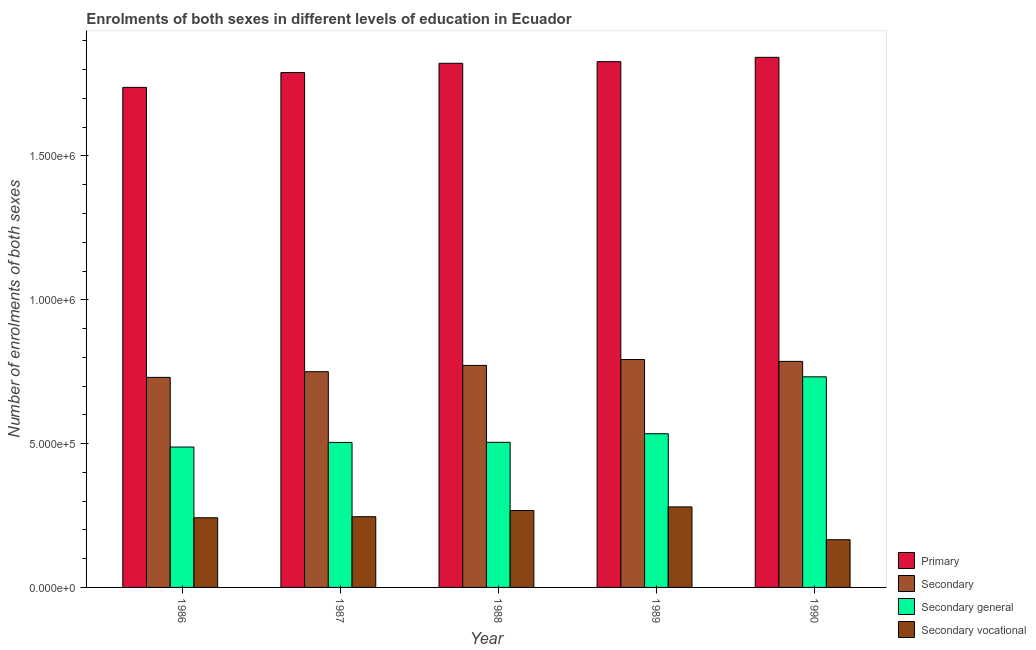How many different coloured bars are there?
Give a very brief answer. 4. Are the number of bars on each tick of the X-axis equal?
Provide a short and direct response. Yes. How many bars are there on the 1st tick from the right?
Your answer should be very brief. 4. What is the number of enrolments in secondary general education in 1987?
Make the answer very short. 5.04e+05. Across all years, what is the maximum number of enrolments in secondary vocational education?
Your answer should be compact. 2.80e+05. Across all years, what is the minimum number of enrolments in secondary education?
Your answer should be compact. 7.30e+05. In which year was the number of enrolments in primary education maximum?
Offer a very short reply. 1990. What is the total number of enrolments in primary education in the graph?
Ensure brevity in your answer.  9.02e+06. What is the difference between the number of enrolments in secondary general education in 1987 and that in 1988?
Your answer should be very brief. -353. What is the difference between the number of enrolments in secondary education in 1989 and the number of enrolments in secondary vocational education in 1986?
Make the answer very short. 6.21e+04. What is the average number of enrolments in secondary general education per year?
Provide a short and direct response. 5.53e+05. In the year 1987, what is the difference between the number of enrolments in secondary vocational education and number of enrolments in secondary education?
Your answer should be compact. 0. What is the ratio of the number of enrolments in secondary education in 1987 to that in 1989?
Ensure brevity in your answer.  0.95. Is the number of enrolments in secondary general education in 1987 less than that in 1990?
Your answer should be compact. Yes. Is the difference between the number of enrolments in primary education in 1986 and 1990 greater than the difference between the number of enrolments in secondary education in 1986 and 1990?
Give a very brief answer. No. What is the difference between the highest and the second highest number of enrolments in primary education?
Give a very brief answer. 1.50e+04. What is the difference between the highest and the lowest number of enrolments in secondary education?
Give a very brief answer. 6.21e+04. In how many years, is the number of enrolments in secondary vocational education greater than the average number of enrolments in secondary vocational education taken over all years?
Provide a short and direct response. 4. Is the sum of the number of enrolments in secondary vocational education in 1987 and 1990 greater than the maximum number of enrolments in primary education across all years?
Provide a succinct answer. Yes. What does the 2nd bar from the left in 1986 represents?
Offer a very short reply. Secondary. What does the 1st bar from the right in 1989 represents?
Ensure brevity in your answer.  Secondary vocational. Is it the case that in every year, the sum of the number of enrolments in primary education and number of enrolments in secondary education is greater than the number of enrolments in secondary general education?
Provide a succinct answer. Yes. Are the values on the major ticks of Y-axis written in scientific E-notation?
Ensure brevity in your answer.  Yes. What is the title of the graph?
Your response must be concise. Enrolments of both sexes in different levels of education in Ecuador. Does "Secondary general" appear as one of the legend labels in the graph?
Your answer should be very brief. Yes. What is the label or title of the X-axis?
Keep it short and to the point. Year. What is the label or title of the Y-axis?
Make the answer very short. Number of enrolments of both sexes. What is the Number of enrolments of both sexes of Primary in 1986?
Provide a succinct answer. 1.74e+06. What is the Number of enrolments of both sexes of Secondary in 1986?
Ensure brevity in your answer.  7.30e+05. What is the Number of enrolments of both sexes of Secondary general in 1986?
Provide a short and direct response. 4.88e+05. What is the Number of enrolments of both sexes of Secondary vocational in 1986?
Your response must be concise. 2.42e+05. What is the Number of enrolments of both sexes of Primary in 1987?
Your response must be concise. 1.79e+06. What is the Number of enrolments of both sexes in Secondary in 1987?
Your response must be concise. 7.50e+05. What is the Number of enrolments of both sexes of Secondary general in 1987?
Ensure brevity in your answer.  5.04e+05. What is the Number of enrolments of both sexes of Secondary vocational in 1987?
Provide a succinct answer. 2.46e+05. What is the Number of enrolments of both sexes of Primary in 1988?
Offer a very short reply. 1.82e+06. What is the Number of enrolments of both sexes in Secondary in 1988?
Offer a terse response. 7.72e+05. What is the Number of enrolments of both sexes in Secondary general in 1988?
Provide a succinct answer. 5.04e+05. What is the Number of enrolments of both sexes in Secondary vocational in 1988?
Offer a terse response. 2.67e+05. What is the Number of enrolments of both sexes in Primary in 1989?
Your answer should be very brief. 1.83e+06. What is the Number of enrolments of both sexes of Secondary in 1989?
Your answer should be compact. 7.92e+05. What is the Number of enrolments of both sexes of Secondary general in 1989?
Keep it short and to the point. 5.34e+05. What is the Number of enrolments of both sexes in Secondary vocational in 1989?
Make the answer very short. 2.80e+05. What is the Number of enrolments of both sexes in Primary in 1990?
Your answer should be compact. 1.84e+06. What is the Number of enrolments of both sexes in Secondary in 1990?
Provide a succinct answer. 7.86e+05. What is the Number of enrolments of both sexes of Secondary general in 1990?
Provide a succinct answer. 7.32e+05. What is the Number of enrolments of both sexes in Secondary vocational in 1990?
Make the answer very short. 1.66e+05. Across all years, what is the maximum Number of enrolments of both sexes in Primary?
Your answer should be very brief. 1.84e+06. Across all years, what is the maximum Number of enrolments of both sexes in Secondary?
Offer a terse response. 7.92e+05. Across all years, what is the maximum Number of enrolments of both sexes of Secondary general?
Give a very brief answer. 7.32e+05. Across all years, what is the maximum Number of enrolments of both sexes of Secondary vocational?
Your response must be concise. 2.80e+05. Across all years, what is the minimum Number of enrolments of both sexes in Primary?
Give a very brief answer. 1.74e+06. Across all years, what is the minimum Number of enrolments of both sexes in Secondary?
Your answer should be very brief. 7.30e+05. Across all years, what is the minimum Number of enrolments of both sexes in Secondary general?
Your answer should be compact. 4.88e+05. Across all years, what is the minimum Number of enrolments of both sexes in Secondary vocational?
Ensure brevity in your answer.  1.66e+05. What is the total Number of enrolments of both sexes of Primary in the graph?
Provide a succinct answer. 9.02e+06. What is the total Number of enrolments of both sexes of Secondary in the graph?
Your answer should be compact. 3.83e+06. What is the total Number of enrolments of both sexes of Secondary general in the graph?
Make the answer very short. 2.76e+06. What is the total Number of enrolments of both sexes of Secondary vocational in the graph?
Offer a terse response. 1.20e+06. What is the difference between the Number of enrolments of both sexes in Primary in 1986 and that in 1987?
Your answer should be very brief. -5.14e+04. What is the difference between the Number of enrolments of both sexes of Secondary in 1986 and that in 1987?
Provide a succinct answer. -1.98e+04. What is the difference between the Number of enrolments of both sexes of Secondary general in 1986 and that in 1987?
Make the answer very short. -1.60e+04. What is the difference between the Number of enrolments of both sexes of Secondary vocational in 1986 and that in 1987?
Ensure brevity in your answer.  -3742. What is the difference between the Number of enrolments of both sexes in Primary in 1986 and that in 1988?
Your answer should be compact. -8.37e+04. What is the difference between the Number of enrolments of both sexes of Secondary in 1986 and that in 1988?
Provide a short and direct response. -4.17e+04. What is the difference between the Number of enrolments of both sexes in Secondary general in 1986 and that in 1988?
Make the answer very short. -1.64e+04. What is the difference between the Number of enrolments of both sexes in Secondary vocational in 1986 and that in 1988?
Give a very brief answer. -2.53e+04. What is the difference between the Number of enrolments of both sexes of Primary in 1986 and that in 1989?
Provide a short and direct response. -8.94e+04. What is the difference between the Number of enrolments of both sexes in Secondary in 1986 and that in 1989?
Provide a succinct answer. -6.21e+04. What is the difference between the Number of enrolments of both sexes of Secondary general in 1986 and that in 1989?
Give a very brief answer. -4.63e+04. What is the difference between the Number of enrolments of both sexes in Secondary vocational in 1986 and that in 1989?
Provide a succinct answer. -3.78e+04. What is the difference between the Number of enrolments of both sexes in Primary in 1986 and that in 1990?
Your response must be concise. -1.04e+05. What is the difference between the Number of enrolments of both sexes in Secondary in 1986 and that in 1990?
Ensure brevity in your answer.  -5.56e+04. What is the difference between the Number of enrolments of both sexes of Secondary general in 1986 and that in 1990?
Your answer should be very brief. -2.44e+05. What is the difference between the Number of enrolments of both sexes in Secondary vocational in 1986 and that in 1990?
Keep it short and to the point. 7.63e+04. What is the difference between the Number of enrolments of both sexes in Primary in 1987 and that in 1988?
Ensure brevity in your answer.  -3.23e+04. What is the difference between the Number of enrolments of both sexes in Secondary in 1987 and that in 1988?
Offer a terse response. -2.19e+04. What is the difference between the Number of enrolments of both sexes of Secondary general in 1987 and that in 1988?
Keep it short and to the point. -353. What is the difference between the Number of enrolments of both sexes of Secondary vocational in 1987 and that in 1988?
Provide a succinct answer. -2.16e+04. What is the difference between the Number of enrolments of both sexes in Primary in 1987 and that in 1989?
Your response must be concise. -3.79e+04. What is the difference between the Number of enrolments of both sexes of Secondary in 1987 and that in 1989?
Offer a terse response. -4.23e+04. What is the difference between the Number of enrolments of both sexes in Secondary general in 1987 and that in 1989?
Your response must be concise. -3.02e+04. What is the difference between the Number of enrolments of both sexes of Secondary vocational in 1987 and that in 1989?
Offer a terse response. -3.41e+04. What is the difference between the Number of enrolments of both sexes in Primary in 1987 and that in 1990?
Offer a very short reply. -5.30e+04. What is the difference between the Number of enrolments of both sexes of Secondary in 1987 and that in 1990?
Offer a terse response. -3.58e+04. What is the difference between the Number of enrolments of both sexes in Secondary general in 1987 and that in 1990?
Keep it short and to the point. -2.28e+05. What is the difference between the Number of enrolments of both sexes of Secondary vocational in 1987 and that in 1990?
Keep it short and to the point. 8.00e+04. What is the difference between the Number of enrolments of both sexes in Primary in 1988 and that in 1989?
Give a very brief answer. -5668. What is the difference between the Number of enrolments of both sexes in Secondary in 1988 and that in 1989?
Offer a very short reply. -2.04e+04. What is the difference between the Number of enrolments of both sexes in Secondary general in 1988 and that in 1989?
Offer a very short reply. -2.99e+04. What is the difference between the Number of enrolments of both sexes of Secondary vocational in 1988 and that in 1989?
Provide a short and direct response. -1.25e+04. What is the difference between the Number of enrolments of both sexes of Primary in 1988 and that in 1990?
Offer a very short reply. -2.07e+04. What is the difference between the Number of enrolments of both sexes in Secondary in 1988 and that in 1990?
Keep it short and to the point. -1.39e+04. What is the difference between the Number of enrolments of both sexes in Secondary general in 1988 and that in 1990?
Your answer should be very brief. -2.28e+05. What is the difference between the Number of enrolments of both sexes of Secondary vocational in 1988 and that in 1990?
Give a very brief answer. 1.02e+05. What is the difference between the Number of enrolments of both sexes in Primary in 1989 and that in 1990?
Your answer should be compact. -1.50e+04. What is the difference between the Number of enrolments of both sexes of Secondary in 1989 and that in 1990?
Your answer should be very brief. 6453. What is the difference between the Number of enrolments of both sexes in Secondary general in 1989 and that in 1990?
Give a very brief answer. -1.98e+05. What is the difference between the Number of enrolments of both sexes in Secondary vocational in 1989 and that in 1990?
Your answer should be very brief. 1.14e+05. What is the difference between the Number of enrolments of both sexes in Primary in 1986 and the Number of enrolments of both sexes in Secondary in 1987?
Offer a terse response. 9.89e+05. What is the difference between the Number of enrolments of both sexes in Primary in 1986 and the Number of enrolments of both sexes in Secondary general in 1987?
Your answer should be very brief. 1.23e+06. What is the difference between the Number of enrolments of both sexes in Primary in 1986 and the Number of enrolments of both sexes in Secondary vocational in 1987?
Ensure brevity in your answer.  1.49e+06. What is the difference between the Number of enrolments of both sexes of Secondary in 1986 and the Number of enrolments of both sexes of Secondary general in 1987?
Make the answer very short. 2.26e+05. What is the difference between the Number of enrolments of both sexes of Secondary in 1986 and the Number of enrolments of both sexes of Secondary vocational in 1987?
Your answer should be compact. 4.84e+05. What is the difference between the Number of enrolments of both sexes of Secondary general in 1986 and the Number of enrolments of both sexes of Secondary vocational in 1987?
Provide a short and direct response. 2.42e+05. What is the difference between the Number of enrolments of both sexes in Primary in 1986 and the Number of enrolments of both sexes in Secondary in 1988?
Give a very brief answer. 9.67e+05. What is the difference between the Number of enrolments of both sexes in Primary in 1986 and the Number of enrolments of both sexes in Secondary general in 1988?
Your answer should be compact. 1.23e+06. What is the difference between the Number of enrolments of both sexes of Primary in 1986 and the Number of enrolments of both sexes of Secondary vocational in 1988?
Offer a very short reply. 1.47e+06. What is the difference between the Number of enrolments of both sexes of Secondary in 1986 and the Number of enrolments of both sexes of Secondary general in 1988?
Offer a terse response. 2.26e+05. What is the difference between the Number of enrolments of both sexes in Secondary in 1986 and the Number of enrolments of both sexes in Secondary vocational in 1988?
Provide a short and direct response. 4.63e+05. What is the difference between the Number of enrolments of both sexes of Secondary general in 1986 and the Number of enrolments of both sexes of Secondary vocational in 1988?
Offer a very short reply. 2.21e+05. What is the difference between the Number of enrolments of both sexes in Primary in 1986 and the Number of enrolments of both sexes in Secondary in 1989?
Offer a terse response. 9.46e+05. What is the difference between the Number of enrolments of both sexes of Primary in 1986 and the Number of enrolments of both sexes of Secondary general in 1989?
Keep it short and to the point. 1.20e+06. What is the difference between the Number of enrolments of both sexes of Primary in 1986 and the Number of enrolments of both sexes of Secondary vocational in 1989?
Give a very brief answer. 1.46e+06. What is the difference between the Number of enrolments of both sexes of Secondary in 1986 and the Number of enrolments of both sexes of Secondary general in 1989?
Offer a very short reply. 1.96e+05. What is the difference between the Number of enrolments of both sexes of Secondary in 1986 and the Number of enrolments of both sexes of Secondary vocational in 1989?
Provide a succinct answer. 4.50e+05. What is the difference between the Number of enrolments of both sexes of Secondary general in 1986 and the Number of enrolments of both sexes of Secondary vocational in 1989?
Keep it short and to the point. 2.08e+05. What is the difference between the Number of enrolments of both sexes of Primary in 1986 and the Number of enrolments of both sexes of Secondary in 1990?
Your answer should be very brief. 9.53e+05. What is the difference between the Number of enrolments of both sexes of Primary in 1986 and the Number of enrolments of both sexes of Secondary general in 1990?
Your response must be concise. 1.01e+06. What is the difference between the Number of enrolments of both sexes of Primary in 1986 and the Number of enrolments of both sexes of Secondary vocational in 1990?
Ensure brevity in your answer.  1.57e+06. What is the difference between the Number of enrolments of both sexes in Secondary in 1986 and the Number of enrolments of both sexes in Secondary general in 1990?
Ensure brevity in your answer.  -1970. What is the difference between the Number of enrolments of both sexes in Secondary in 1986 and the Number of enrolments of both sexes in Secondary vocational in 1990?
Offer a terse response. 5.64e+05. What is the difference between the Number of enrolments of both sexes of Secondary general in 1986 and the Number of enrolments of both sexes of Secondary vocational in 1990?
Make the answer very short. 3.22e+05. What is the difference between the Number of enrolments of both sexes of Primary in 1987 and the Number of enrolments of both sexes of Secondary in 1988?
Keep it short and to the point. 1.02e+06. What is the difference between the Number of enrolments of both sexes in Primary in 1987 and the Number of enrolments of both sexes in Secondary general in 1988?
Offer a terse response. 1.29e+06. What is the difference between the Number of enrolments of both sexes in Primary in 1987 and the Number of enrolments of both sexes in Secondary vocational in 1988?
Give a very brief answer. 1.52e+06. What is the difference between the Number of enrolments of both sexes of Secondary in 1987 and the Number of enrolments of both sexes of Secondary general in 1988?
Offer a terse response. 2.46e+05. What is the difference between the Number of enrolments of both sexes in Secondary in 1987 and the Number of enrolments of both sexes in Secondary vocational in 1988?
Your answer should be very brief. 4.83e+05. What is the difference between the Number of enrolments of both sexes in Secondary general in 1987 and the Number of enrolments of both sexes in Secondary vocational in 1988?
Give a very brief answer. 2.37e+05. What is the difference between the Number of enrolments of both sexes in Primary in 1987 and the Number of enrolments of both sexes in Secondary in 1989?
Give a very brief answer. 9.98e+05. What is the difference between the Number of enrolments of both sexes in Primary in 1987 and the Number of enrolments of both sexes in Secondary general in 1989?
Offer a terse response. 1.26e+06. What is the difference between the Number of enrolments of both sexes of Primary in 1987 and the Number of enrolments of both sexes of Secondary vocational in 1989?
Offer a terse response. 1.51e+06. What is the difference between the Number of enrolments of both sexes of Secondary in 1987 and the Number of enrolments of both sexes of Secondary general in 1989?
Your answer should be compact. 2.16e+05. What is the difference between the Number of enrolments of both sexes in Secondary in 1987 and the Number of enrolments of both sexes in Secondary vocational in 1989?
Ensure brevity in your answer.  4.70e+05. What is the difference between the Number of enrolments of both sexes of Secondary general in 1987 and the Number of enrolments of both sexes of Secondary vocational in 1989?
Your response must be concise. 2.24e+05. What is the difference between the Number of enrolments of both sexes of Primary in 1987 and the Number of enrolments of both sexes of Secondary in 1990?
Your answer should be very brief. 1.00e+06. What is the difference between the Number of enrolments of both sexes in Primary in 1987 and the Number of enrolments of both sexes in Secondary general in 1990?
Offer a terse response. 1.06e+06. What is the difference between the Number of enrolments of both sexes of Primary in 1987 and the Number of enrolments of both sexes of Secondary vocational in 1990?
Your answer should be compact. 1.62e+06. What is the difference between the Number of enrolments of both sexes in Secondary in 1987 and the Number of enrolments of both sexes in Secondary general in 1990?
Provide a succinct answer. 1.78e+04. What is the difference between the Number of enrolments of both sexes of Secondary in 1987 and the Number of enrolments of both sexes of Secondary vocational in 1990?
Provide a short and direct response. 5.84e+05. What is the difference between the Number of enrolments of both sexes of Secondary general in 1987 and the Number of enrolments of both sexes of Secondary vocational in 1990?
Give a very brief answer. 3.38e+05. What is the difference between the Number of enrolments of both sexes in Primary in 1988 and the Number of enrolments of both sexes in Secondary in 1989?
Offer a very short reply. 1.03e+06. What is the difference between the Number of enrolments of both sexes in Primary in 1988 and the Number of enrolments of both sexes in Secondary general in 1989?
Provide a short and direct response. 1.29e+06. What is the difference between the Number of enrolments of both sexes in Primary in 1988 and the Number of enrolments of both sexes in Secondary vocational in 1989?
Provide a succinct answer. 1.54e+06. What is the difference between the Number of enrolments of both sexes in Secondary in 1988 and the Number of enrolments of both sexes in Secondary general in 1989?
Your answer should be very brief. 2.38e+05. What is the difference between the Number of enrolments of both sexes in Secondary in 1988 and the Number of enrolments of both sexes in Secondary vocational in 1989?
Keep it short and to the point. 4.92e+05. What is the difference between the Number of enrolments of both sexes of Secondary general in 1988 and the Number of enrolments of both sexes of Secondary vocational in 1989?
Your answer should be compact. 2.24e+05. What is the difference between the Number of enrolments of both sexes in Primary in 1988 and the Number of enrolments of both sexes in Secondary in 1990?
Your answer should be very brief. 1.04e+06. What is the difference between the Number of enrolments of both sexes of Primary in 1988 and the Number of enrolments of both sexes of Secondary general in 1990?
Give a very brief answer. 1.09e+06. What is the difference between the Number of enrolments of both sexes of Primary in 1988 and the Number of enrolments of both sexes of Secondary vocational in 1990?
Your answer should be very brief. 1.66e+06. What is the difference between the Number of enrolments of both sexes of Secondary in 1988 and the Number of enrolments of both sexes of Secondary general in 1990?
Give a very brief answer. 3.97e+04. What is the difference between the Number of enrolments of both sexes in Secondary in 1988 and the Number of enrolments of both sexes in Secondary vocational in 1990?
Your answer should be very brief. 6.06e+05. What is the difference between the Number of enrolments of both sexes of Secondary general in 1988 and the Number of enrolments of both sexes of Secondary vocational in 1990?
Offer a very short reply. 3.39e+05. What is the difference between the Number of enrolments of both sexes in Primary in 1989 and the Number of enrolments of both sexes in Secondary in 1990?
Ensure brevity in your answer.  1.04e+06. What is the difference between the Number of enrolments of both sexes of Primary in 1989 and the Number of enrolments of both sexes of Secondary general in 1990?
Ensure brevity in your answer.  1.10e+06. What is the difference between the Number of enrolments of both sexes of Primary in 1989 and the Number of enrolments of both sexes of Secondary vocational in 1990?
Your answer should be very brief. 1.66e+06. What is the difference between the Number of enrolments of both sexes in Secondary in 1989 and the Number of enrolments of both sexes in Secondary general in 1990?
Your answer should be very brief. 6.01e+04. What is the difference between the Number of enrolments of both sexes of Secondary in 1989 and the Number of enrolments of both sexes of Secondary vocational in 1990?
Make the answer very short. 6.26e+05. What is the difference between the Number of enrolments of both sexes in Secondary general in 1989 and the Number of enrolments of both sexes in Secondary vocational in 1990?
Your response must be concise. 3.69e+05. What is the average Number of enrolments of both sexes of Primary per year?
Make the answer very short. 1.80e+06. What is the average Number of enrolments of both sexes of Secondary per year?
Provide a short and direct response. 7.66e+05. What is the average Number of enrolments of both sexes in Secondary general per year?
Ensure brevity in your answer.  5.53e+05. What is the average Number of enrolments of both sexes of Secondary vocational per year?
Provide a succinct answer. 2.40e+05. In the year 1986, what is the difference between the Number of enrolments of both sexes of Primary and Number of enrolments of both sexes of Secondary?
Your answer should be very brief. 1.01e+06. In the year 1986, what is the difference between the Number of enrolments of both sexes of Primary and Number of enrolments of both sexes of Secondary general?
Make the answer very short. 1.25e+06. In the year 1986, what is the difference between the Number of enrolments of both sexes of Primary and Number of enrolments of both sexes of Secondary vocational?
Make the answer very short. 1.50e+06. In the year 1986, what is the difference between the Number of enrolments of both sexes of Secondary and Number of enrolments of both sexes of Secondary general?
Keep it short and to the point. 2.42e+05. In the year 1986, what is the difference between the Number of enrolments of both sexes of Secondary and Number of enrolments of both sexes of Secondary vocational?
Provide a succinct answer. 4.88e+05. In the year 1986, what is the difference between the Number of enrolments of both sexes in Secondary general and Number of enrolments of both sexes in Secondary vocational?
Make the answer very short. 2.46e+05. In the year 1987, what is the difference between the Number of enrolments of both sexes of Primary and Number of enrolments of both sexes of Secondary?
Your answer should be compact. 1.04e+06. In the year 1987, what is the difference between the Number of enrolments of both sexes of Primary and Number of enrolments of both sexes of Secondary general?
Offer a very short reply. 1.29e+06. In the year 1987, what is the difference between the Number of enrolments of both sexes in Primary and Number of enrolments of both sexes in Secondary vocational?
Provide a short and direct response. 1.54e+06. In the year 1987, what is the difference between the Number of enrolments of both sexes in Secondary and Number of enrolments of both sexes in Secondary general?
Offer a terse response. 2.46e+05. In the year 1987, what is the difference between the Number of enrolments of both sexes in Secondary and Number of enrolments of both sexes in Secondary vocational?
Provide a succinct answer. 5.04e+05. In the year 1987, what is the difference between the Number of enrolments of both sexes of Secondary general and Number of enrolments of both sexes of Secondary vocational?
Your answer should be very brief. 2.58e+05. In the year 1988, what is the difference between the Number of enrolments of both sexes in Primary and Number of enrolments of both sexes in Secondary?
Your answer should be compact. 1.05e+06. In the year 1988, what is the difference between the Number of enrolments of both sexes in Primary and Number of enrolments of both sexes in Secondary general?
Give a very brief answer. 1.32e+06. In the year 1988, what is the difference between the Number of enrolments of both sexes of Primary and Number of enrolments of both sexes of Secondary vocational?
Ensure brevity in your answer.  1.55e+06. In the year 1988, what is the difference between the Number of enrolments of both sexes in Secondary and Number of enrolments of both sexes in Secondary general?
Offer a very short reply. 2.67e+05. In the year 1988, what is the difference between the Number of enrolments of both sexes of Secondary and Number of enrolments of both sexes of Secondary vocational?
Your response must be concise. 5.04e+05. In the year 1988, what is the difference between the Number of enrolments of both sexes in Secondary general and Number of enrolments of both sexes in Secondary vocational?
Give a very brief answer. 2.37e+05. In the year 1989, what is the difference between the Number of enrolments of both sexes in Primary and Number of enrolments of both sexes in Secondary?
Offer a very short reply. 1.04e+06. In the year 1989, what is the difference between the Number of enrolments of both sexes in Primary and Number of enrolments of both sexes in Secondary general?
Ensure brevity in your answer.  1.29e+06. In the year 1989, what is the difference between the Number of enrolments of both sexes in Primary and Number of enrolments of both sexes in Secondary vocational?
Offer a terse response. 1.55e+06. In the year 1989, what is the difference between the Number of enrolments of both sexes of Secondary and Number of enrolments of both sexes of Secondary general?
Ensure brevity in your answer.  2.58e+05. In the year 1989, what is the difference between the Number of enrolments of both sexes of Secondary and Number of enrolments of both sexes of Secondary vocational?
Keep it short and to the point. 5.12e+05. In the year 1989, what is the difference between the Number of enrolments of both sexes in Secondary general and Number of enrolments of both sexes in Secondary vocational?
Your answer should be compact. 2.54e+05. In the year 1990, what is the difference between the Number of enrolments of both sexes of Primary and Number of enrolments of both sexes of Secondary?
Offer a terse response. 1.06e+06. In the year 1990, what is the difference between the Number of enrolments of both sexes in Primary and Number of enrolments of both sexes in Secondary general?
Your answer should be very brief. 1.11e+06. In the year 1990, what is the difference between the Number of enrolments of both sexes of Primary and Number of enrolments of both sexes of Secondary vocational?
Your answer should be very brief. 1.68e+06. In the year 1990, what is the difference between the Number of enrolments of both sexes in Secondary and Number of enrolments of both sexes in Secondary general?
Ensure brevity in your answer.  5.36e+04. In the year 1990, what is the difference between the Number of enrolments of both sexes of Secondary and Number of enrolments of both sexes of Secondary vocational?
Your answer should be very brief. 6.20e+05. In the year 1990, what is the difference between the Number of enrolments of both sexes of Secondary general and Number of enrolments of both sexes of Secondary vocational?
Your answer should be very brief. 5.66e+05. What is the ratio of the Number of enrolments of both sexes of Primary in 1986 to that in 1987?
Your response must be concise. 0.97. What is the ratio of the Number of enrolments of both sexes in Secondary in 1986 to that in 1987?
Your answer should be compact. 0.97. What is the ratio of the Number of enrolments of both sexes in Secondary general in 1986 to that in 1987?
Ensure brevity in your answer.  0.97. What is the ratio of the Number of enrolments of both sexes in Primary in 1986 to that in 1988?
Provide a short and direct response. 0.95. What is the ratio of the Number of enrolments of both sexes in Secondary in 1986 to that in 1988?
Provide a succinct answer. 0.95. What is the ratio of the Number of enrolments of both sexes in Secondary general in 1986 to that in 1988?
Provide a succinct answer. 0.97. What is the ratio of the Number of enrolments of both sexes of Secondary vocational in 1986 to that in 1988?
Make the answer very short. 0.91. What is the ratio of the Number of enrolments of both sexes of Primary in 1986 to that in 1989?
Keep it short and to the point. 0.95. What is the ratio of the Number of enrolments of both sexes of Secondary in 1986 to that in 1989?
Provide a short and direct response. 0.92. What is the ratio of the Number of enrolments of both sexes in Secondary general in 1986 to that in 1989?
Ensure brevity in your answer.  0.91. What is the ratio of the Number of enrolments of both sexes in Secondary vocational in 1986 to that in 1989?
Ensure brevity in your answer.  0.86. What is the ratio of the Number of enrolments of both sexes in Primary in 1986 to that in 1990?
Provide a short and direct response. 0.94. What is the ratio of the Number of enrolments of both sexes in Secondary in 1986 to that in 1990?
Your response must be concise. 0.93. What is the ratio of the Number of enrolments of both sexes in Secondary general in 1986 to that in 1990?
Your answer should be very brief. 0.67. What is the ratio of the Number of enrolments of both sexes of Secondary vocational in 1986 to that in 1990?
Keep it short and to the point. 1.46. What is the ratio of the Number of enrolments of both sexes in Primary in 1987 to that in 1988?
Give a very brief answer. 0.98. What is the ratio of the Number of enrolments of both sexes of Secondary in 1987 to that in 1988?
Keep it short and to the point. 0.97. What is the ratio of the Number of enrolments of both sexes in Secondary vocational in 1987 to that in 1988?
Offer a terse response. 0.92. What is the ratio of the Number of enrolments of both sexes in Primary in 1987 to that in 1989?
Provide a succinct answer. 0.98. What is the ratio of the Number of enrolments of both sexes in Secondary in 1987 to that in 1989?
Your answer should be compact. 0.95. What is the ratio of the Number of enrolments of both sexes in Secondary general in 1987 to that in 1989?
Offer a very short reply. 0.94. What is the ratio of the Number of enrolments of both sexes in Secondary vocational in 1987 to that in 1989?
Offer a very short reply. 0.88. What is the ratio of the Number of enrolments of both sexes in Primary in 1987 to that in 1990?
Keep it short and to the point. 0.97. What is the ratio of the Number of enrolments of both sexes of Secondary in 1987 to that in 1990?
Give a very brief answer. 0.95. What is the ratio of the Number of enrolments of both sexes of Secondary general in 1987 to that in 1990?
Your answer should be very brief. 0.69. What is the ratio of the Number of enrolments of both sexes of Secondary vocational in 1987 to that in 1990?
Your answer should be compact. 1.48. What is the ratio of the Number of enrolments of both sexes of Secondary in 1988 to that in 1989?
Offer a terse response. 0.97. What is the ratio of the Number of enrolments of both sexes of Secondary general in 1988 to that in 1989?
Offer a very short reply. 0.94. What is the ratio of the Number of enrolments of both sexes of Secondary vocational in 1988 to that in 1989?
Provide a succinct answer. 0.96. What is the ratio of the Number of enrolments of both sexes of Primary in 1988 to that in 1990?
Provide a short and direct response. 0.99. What is the ratio of the Number of enrolments of both sexes of Secondary in 1988 to that in 1990?
Offer a very short reply. 0.98. What is the ratio of the Number of enrolments of both sexes of Secondary general in 1988 to that in 1990?
Provide a succinct answer. 0.69. What is the ratio of the Number of enrolments of both sexes in Secondary vocational in 1988 to that in 1990?
Keep it short and to the point. 1.61. What is the ratio of the Number of enrolments of both sexes in Secondary in 1989 to that in 1990?
Your answer should be very brief. 1.01. What is the ratio of the Number of enrolments of both sexes in Secondary general in 1989 to that in 1990?
Provide a succinct answer. 0.73. What is the ratio of the Number of enrolments of both sexes in Secondary vocational in 1989 to that in 1990?
Keep it short and to the point. 1.69. What is the difference between the highest and the second highest Number of enrolments of both sexes of Primary?
Offer a very short reply. 1.50e+04. What is the difference between the highest and the second highest Number of enrolments of both sexes in Secondary?
Provide a succinct answer. 6453. What is the difference between the highest and the second highest Number of enrolments of both sexes in Secondary general?
Keep it short and to the point. 1.98e+05. What is the difference between the highest and the second highest Number of enrolments of both sexes of Secondary vocational?
Your answer should be compact. 1.25e+04. What is the difference between the highest and the lowest Number of enrolments of both sexes in Primary?
Your response must be concise. 1.04e+05. What is the difference between the highest and the lowest Number of enrolments of both sexes of Secondary?
Keep it short and to the point. 6.21e+04. What is the difference between the highest and the lowest Number of enrolments of both sexes in Secondary general?
Your answer should be very brief. 2.44e+05. What is the difference between the highest and the lowest Number of enrolments of both sexes in Secondary vocational?
Your response must be concise. 1.14e+05. 